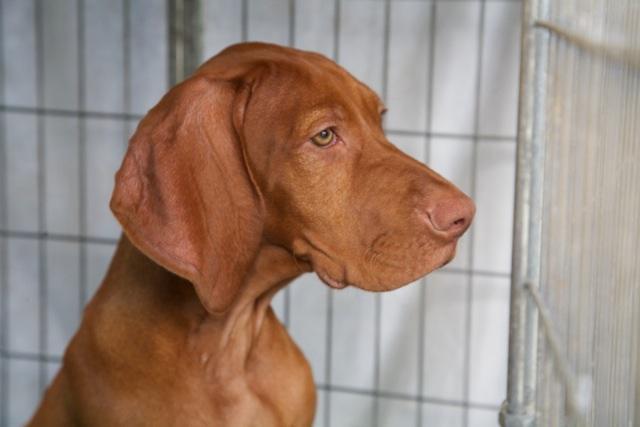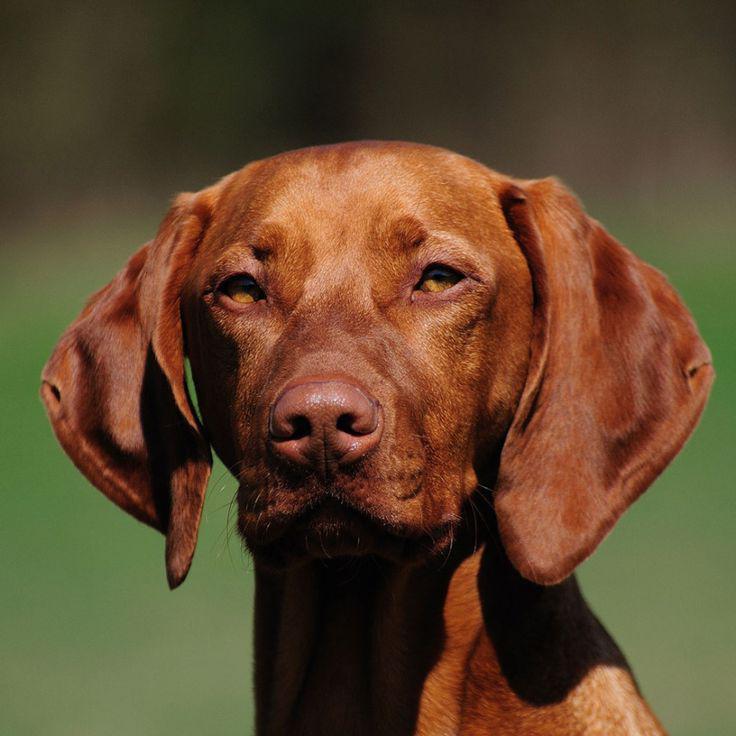The first image is the image on the left, the second image is the image on the right. Assess this claim about the two images: "In at least one image, there is a redbone coonhound sitting with his head facing left.". Correct or not? Answer yes or no. No. The first image is the image on the left, the second image is the image on the right. For the images displayed, is the sentence "The right image contains a red-orange dog with an upright head gazing straight ahead, and the left image contains a dog with its muzzle pointing rightward." factually correct? Answer yes or no. Yes. 